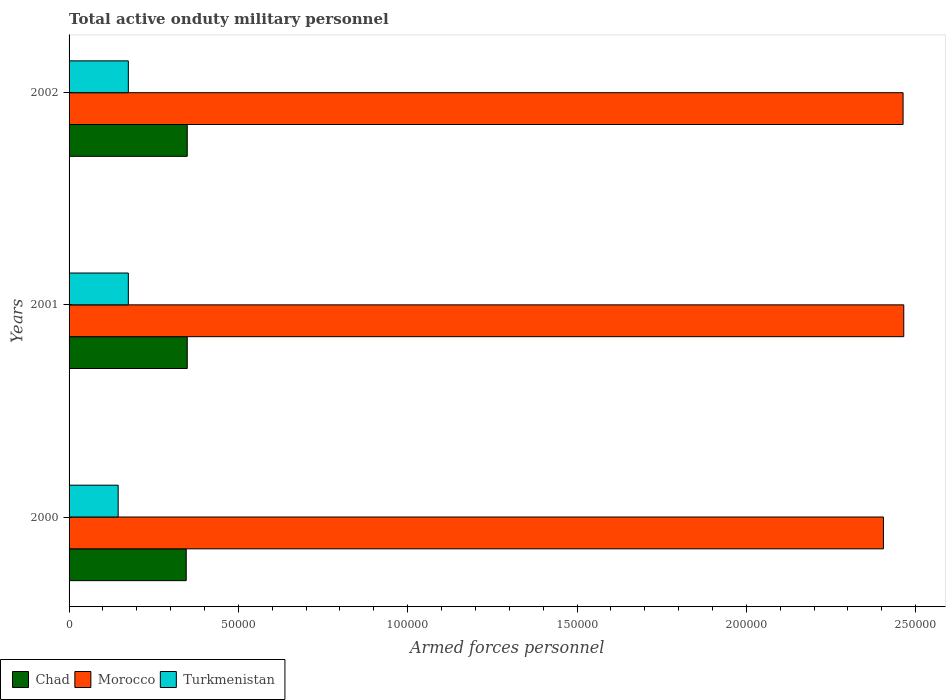How many different coloured bars are there?
Your response must be concise. 3. Are the number of bars per tick equal to the number of legend labels?
Provide a succinct answer. Yes. Are the number of bars on each tick of the Y-axis equal?
Your answer should be very brief. Yes. What is the label of the 1st group of bars from the top?
Keep it short and to the point. 2002. What is the number of armed forces personnel in Chad in 2000?
Your answer should be compact. 3.46e+04. Across all years, what is the maximum number of armed forces personnel in Morocco?
Keep it short and to the point. 2.46e+05. Across all years, what is the minimum number of armed forces personnel in Morocco?
Make the answer very short. 2.40e+05. In which year was the number of armed forces personnel in Turkmenistan minimum?
Keep it short and to the point. 2000. What is the total number of armed forces personnel in Morocco in the graph?
Give a very brief answer. 7.33e+05. What is the difference between the number of armed forces personnel in Chad in 2000 and that in 2002?
Your response must be concise. -300. What is the difference between the number of armed forces personnel in Turkmenistan in 2000 and the number of armed forces personnel in Morocco in 2002?
Offer a terse response. -2.32e+05. What is the average number of armed forces personnel in Morocco per year?
Give a very brief answer. 2.44e+05. In the year 2002, what is the difference between the number of armed forces personnel in Turkmenistan and number of armed forces personnel in Morocco?
Offer a very short reply. -2.29e+05. In how many years, is the number of armed forces personnel in Chad greater than 190000 ?
Ensure brevity in your answer.  0. What is the ratio of the number of armed forces personnel in Morocco in 2000 to that in 2001?
Your answer should be compact. 0.98. What is the difference between the highest and the lowest number of armed forces personnel in Turkmenistan?
Provide a short and direct response. 3000. Is the sum of the number of armed forces personnel in Turkmenistan in 2000 and 2001 greater than the maximum number of armed forces personnel in Morocco across all years?
Offer a terse response. No. What does the 1st bar from the top in 2000 represents?
Your answer should be very brief. Turkmenistan. What does the 1st bar from the bottom in 2002 represents?
Keep it short and to the point. Chad. How many bars are there?
Make the answer very short. 9. Are all the bars in the graph horizontal?
Provide a short and direct response. Yes. How many years are there in the graph?
Make the answer very short. 3. Does the graph contain any zero values?
Ensure brevity in your answer.  No. Does the graph contain grids?
Provide a succinct answer. No. Where does the legend appear in the graph?
Offer a terse response. Bottom left. How many legend labels are there?
Offer a very short reply. 3. How are the legend labels stacked?
Offer a very short reply. Horizontal. What is the title of the graph?
Ensure brevity in your answer.  Total active onduty military personnel. Does "Ethiopia" appear as one of the legend labels in the graph?
Offer a very short reply. No. What is the label or title of the X-axis?
Give a very brief answer. Armed forces personnel. What is the Armed forces personnel of Chad in 2000?
Provide a succinct answer. 3.46e+04. What is the Armed forces personnel in Morocco in 2000?
Make the answer very short. 2.40e+05. What is the Armed forces personnel of Turkmenistan in 2000?
Ensure brevity in your answer.  1.45e+04. What is the Armed forces personnel in Chad in 2001?
Keep it short and to the point. 3.49e+04. What is the Armed forces personnel of Morocco in 2001?
Offer a terse response. 2.46e+05. What is the Armed forces personnel in Turkmenistan in 2001?
Ensure brevity in your answer.  1.75e+04. What is the Armed forces personnel of Chad in 2002?
Offer a terse response. 3.49e+04. What is the Armed forces personnel of Morocco in 2002?
Your response must be concise. 2.46e+05. What is the Armed forces personnel of Turkmenistan in 2002?
Your answer should be very brief. 1.75e+04. Across all years, what is the maximum Armed forces personnel in Chad?
Provide a short and direct response. 3.49e+04. Across all years, what is the maximum Armed forces personnel in Morocco?
Keep it short and to the point. 2.46e+05. Across all years, what is the maximum Armed forces personnel of Turkmenistan?
Your answer should be very brief. 1.75e+04. Across all years, what is the minimum Armed forces personnel of Chad?
Ensure brevity in your answer.  3.46e+04. Across all years, what is the minimum Armed forces personnel of Morocco?
Give a very brief answer. 2.40e+05. Across all years, what is the minimum Armed forces personnel of Turkmenistan?
Your answer should be very brief. 1.45e+04. What is the total Armed forces personnel of Chad in the graph?
Provide a succinct answer. 1.04e+05. What is the total Armed forces personnel in Morocco in the graph?
Your answer should be very brief. 7.33e+05. What is the total Armed forces personnel in Turkmenistan in the graph?
Provide a short and direct response. 4.95e+04. What is the difference between the Armed forces personnel of Chad in 2000 and that in 2001?
Provide a short and direct response. -300. What is the difference between the Armed forces personnel of Morocco in 2000 and that in 2001?
Your answer should be compact. -6000. What is the difference between the Armed forces personnel in Turkmenistan in 2000 and that in 2001?
Ensure brevity in your answer.  -3000. What is the difference between the Armed forces personnel of Chad in 2000 and that in 2002?
Provide a succinct answer. -300. What is the difference between the Armed forces personnel in Morocco in 2000 and that in 2002?
Make the answer very short. -5800. What is the difference between the Armed forces personnel of Turkmenistan in 2000 and that in 2002?
Your answer should be compact. -3000. What is the difference between the Armed forces personnel of Morocco in 2001 and that in 2002?
Make the answer very short. 200. What is the difference between the Armed forces personnel of Turkmenistan in 2001 and that in 2002?
Your answer should be very brief. 0. What is the difference between the Armed forces personnel of Chad in 2000 and the Armed forces personnel of Morocco in 2001?
Offer a terse response. -2.12e+05. What is the difference between the Armed forces personnel of Chad in 2000 and the Armed forces personnel of Turkmenistan in 2001?
Your answer should be very brief. 1.71e+04. What is the difference between the Armed forces personnel of Morocco in 2000 and the Armed forces personnel of Turkmenistan in 2001?
Your answer should be very brief. 2.23e+05. What is the difference between the Armed forces personnel in Chad in 2000 and the Armed forces personnel in Morocco in 2002?
Your answer should be compact. -2.12e+05. What is the difference between the Armed forces personnel of Chad in 2000 and the Armed forces personnel of Turkmenistan in 2002?
Your answer should be compact. 1.71e+04. What is the difference between the Armed forces personnel of Morocco in 2000 and the Armed forces personnel of Turkmenistan in 2002?
Make the answer very short. 2.23e+05. What is the difference between the Armed forces personnel in Chad in 2001 and the Armed forces personnel in Morocco in 2002?
Your response must be concise. -2.11e+05. What is the difference between the Armed forces personnel in Chad in 2001 and the Armed forces personnel in Turkmenistan in 2002?
Offer a very short reply. 1.74e+04. What is the difference between the Armed forces personnel in Morocco in 2001 and the Armed forces personnel in Turkmenistan in 2002?
Your answer should be compact. 2.29e+05. What is the average Armed forces personnel of Chad per year?
Make the answer very short. 3.48e+04. What is the average Armed forces personnel of Morocco per year?
Provide a succinct answer. 2.44e+05. What is the average Armed forces personnel in Turkmenistan per year?
Ensure brevity in your answer.  1.65e+04. In the year 2000, what is the difference between the Armed forces personnel of Chad and Armed forces personnel of Morocco?
Make the answer very short. -2.06e+05. In the year 2000, what is the difference between the Armed forces personnel of Chad and Armed forces personnel of Turkmenistan?
Ensure brevity in your answer.  2.01e+04. In the year 2000, what is the difference between the Armed forces personnel in Morocco and Armed forces personnel in Turkmenistan?
Offer a terse response. 2.26e+05. In the year 2001, what is the difference between the Armed forces personnel in Chad and Armed forces personnel in Morocco?
Make the answer very short. -2.12e+05. In the year 2001, what is the difference between the Armed forces personnel of Chad and Armed forces personnel of Turkmenistan?
Provide a succinct answer. 1.74e+04. In the year 2001, what is the difference between the Armed forces personnel in Morocco and Armed forces personnel in Turkmenistan?
Your answer should be very brief. 2.29e+05. In the year 2002, what is the difference between the Armed forces personnel of Chad and Armed forces personnel of Morocco?
Give a very brief answer. -2.11e+05. In the year 2002, what is the difference between the Armed forces personnel of Chad and Armed forces personnel of Turkmenistan?
Ensure brevity in your answer.  1.74e+04. In the year 2002, what is the difference between the Armed forces personnel of Morocco and Armed forces personnel of Turkmenistan?
Give a very brief answer. 2.29e+05. What is the ratio of the Armed forces personnel of Morocco in 2000 to that in 2001?
Your response must be concise. 0.98. What is the ratio of the Armed forces personnel of Turkmenistan in 2000 to that in 2001?
Make the answer very short. 0.83. What is the ratio of the Armed forces personnel in Morocco in 2000 to that in 2002?
Make the answer very short. 0.98. What is the ratio of the Armed forces personnel of Turkmenistan in 2000 to that in 2002?
Ensure brevity in your answer.  0.83. What is the difference between the highest and the second highest Armed forces personnel in Morocco?
Provide a succinct answer. 200. What is the difference between the highest and the lowest Armed forces personnel of Chad?
Your answer should be compact. 300. What is the difference between the highest and the lowest Armed forces personnel in Morocco?
Give a very brief answer. 6000. What is the difference between the highest and the lowest Armed forces personnel in Turkmenistan?
Your answer should be compact. 3000. 